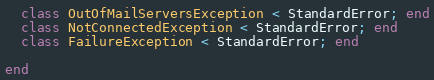<code> <loc_0><loc_0><loc_500><loc_500><_Ruby_>  class OutOfMailServersException < StandardError; end
  class NotConnectedException < StandardError; end
  class FailureException < StandardError; end

end
</code> 